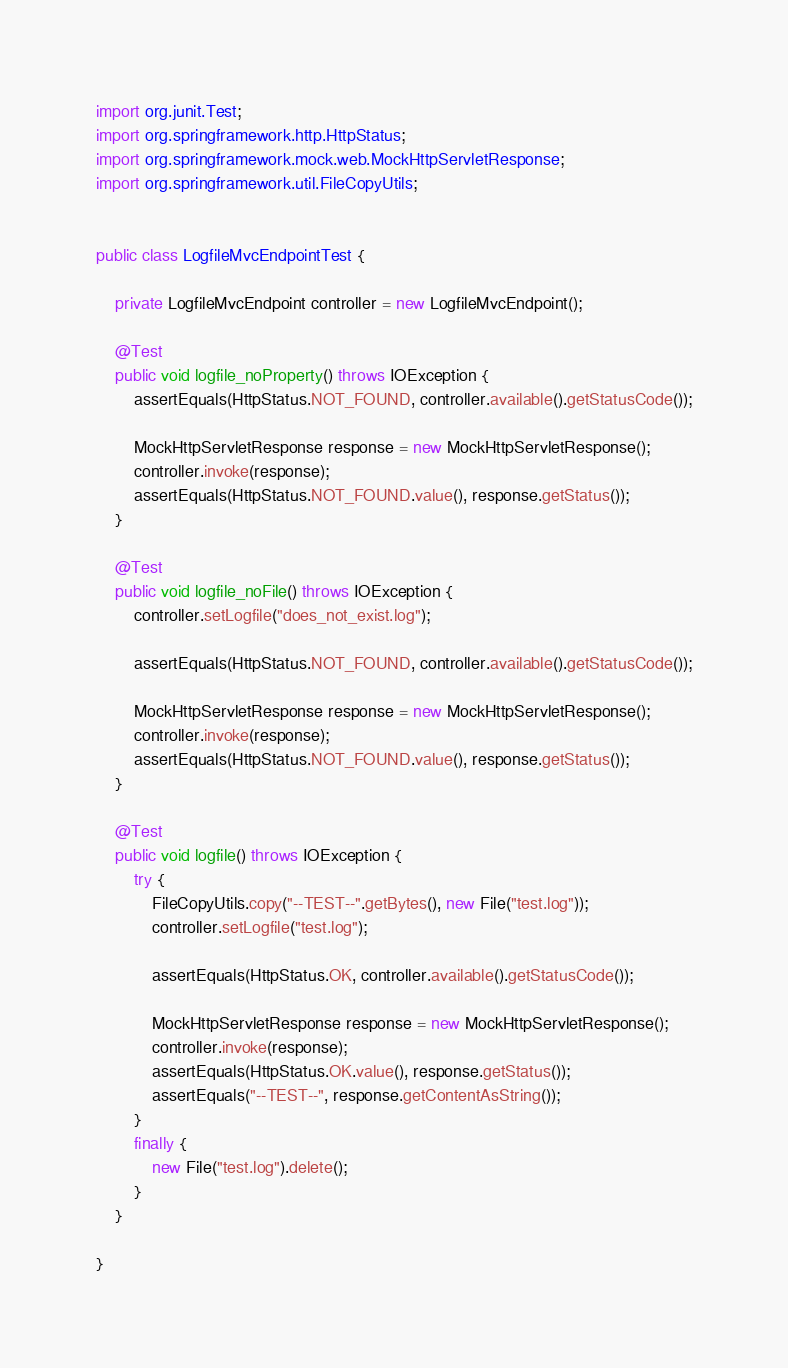Convert code to text. <code><loc_0><loc_0><loc_500><loc_500><_Java_>import org.junit.Test;
import org.springframework.http.HttpStatus;
import org.springframework.mock.web.MockHttpServletResponse;
import org.springframework.util.FileCopyUtils;


public class LogfileMvcEndpointTest {

	private LogfileMvcEndpoint controller = new LogfileMvcEndpoint();

	@Test
	public void logfile_noProperty() throws IOException {
		assertEquals(HttpStatus.NOT_FOUND, controller.available().getStatusCode());

		MockHttpServletResponse response = new MockHttpServletResponse();
		controller.invoke(response);
		assertEquals(HttpStatus.NOT_FOUND.value(), response.getStatus());
	}

	@Test
	public void logfile_noFile() throws IOException {
		controller.setLogfile("does_not_exist.log");

		assertEquals(HttpStatus.NOT_FOUND, controller.available().getStatusCode());

		MockHttpServletResponse response = new MockHttpServletResponse();
		controller.invoke(response);
		assertEquals(HttpStatus.NOT_FOUND.value(), response.getStatus());
	}

	@Test
	public void logfile() throws IOException {
		try {
			FileCopyUtils.copy("--TEST--".getBytes(), new File("test.log"));
			controller.setLogfile("test.log");

			assertEquals(HttpStatus.OK, controller.available().getStatusCode());

			MockHttpServletResponse response = new MockHttpServletResponse();
			controller.invoke(response);
			assertEquals(HttpStatus.OK.value(), response.getStatus());
			assertEquals("--TEST--", response.getContentAsString());
		}
		finally {
			new File("test.log").delete();
		}
	}

}
</code> 